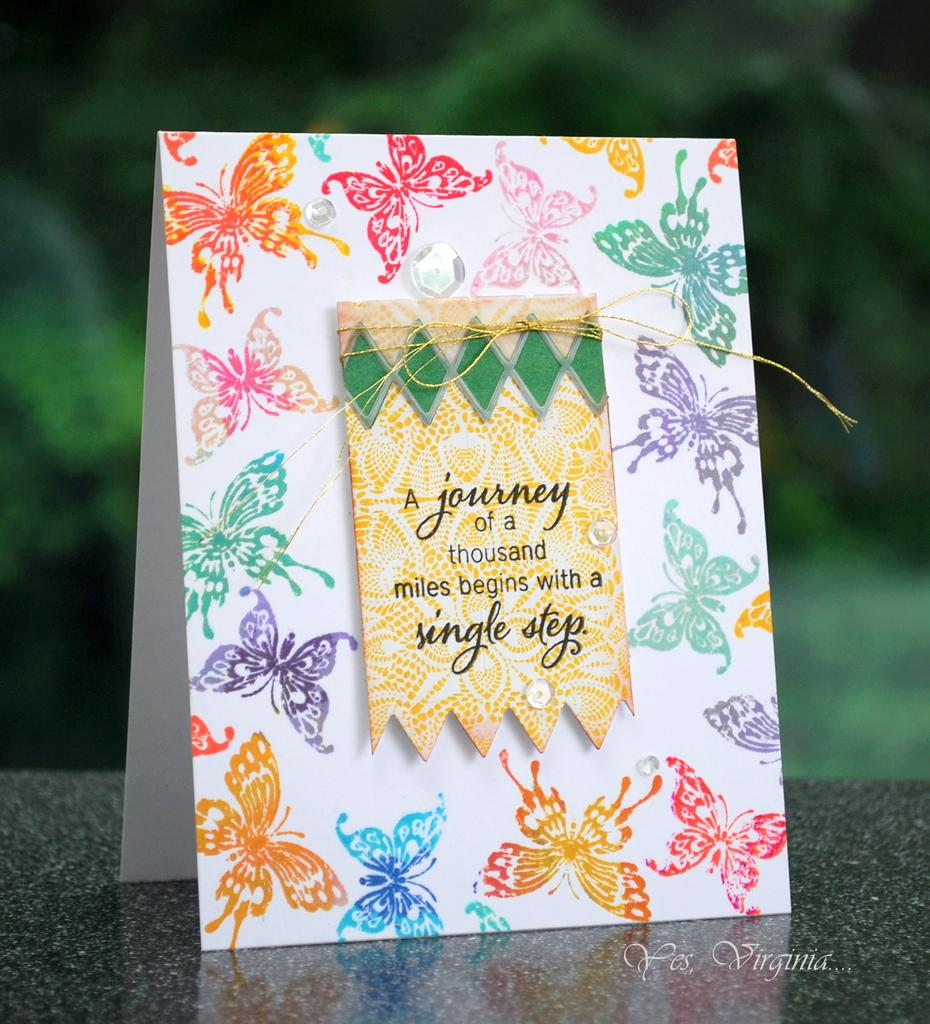What is the main subject of the image? There is a greeting card in the center of the image. Can you describe the background of the image? The background of the image is blurry. How many rabbits can be seen playing with a duck in the image? There are no rabbits or ducks present in the image; it features a greeting card with a blurry background. 